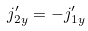Convert formula to latex. <formula><loc_0><loc_0><loc_500><loc_500>j ^ { \prime } _ { 2 y } = - j ^ { \prime } _ { 1 y }</formula> 